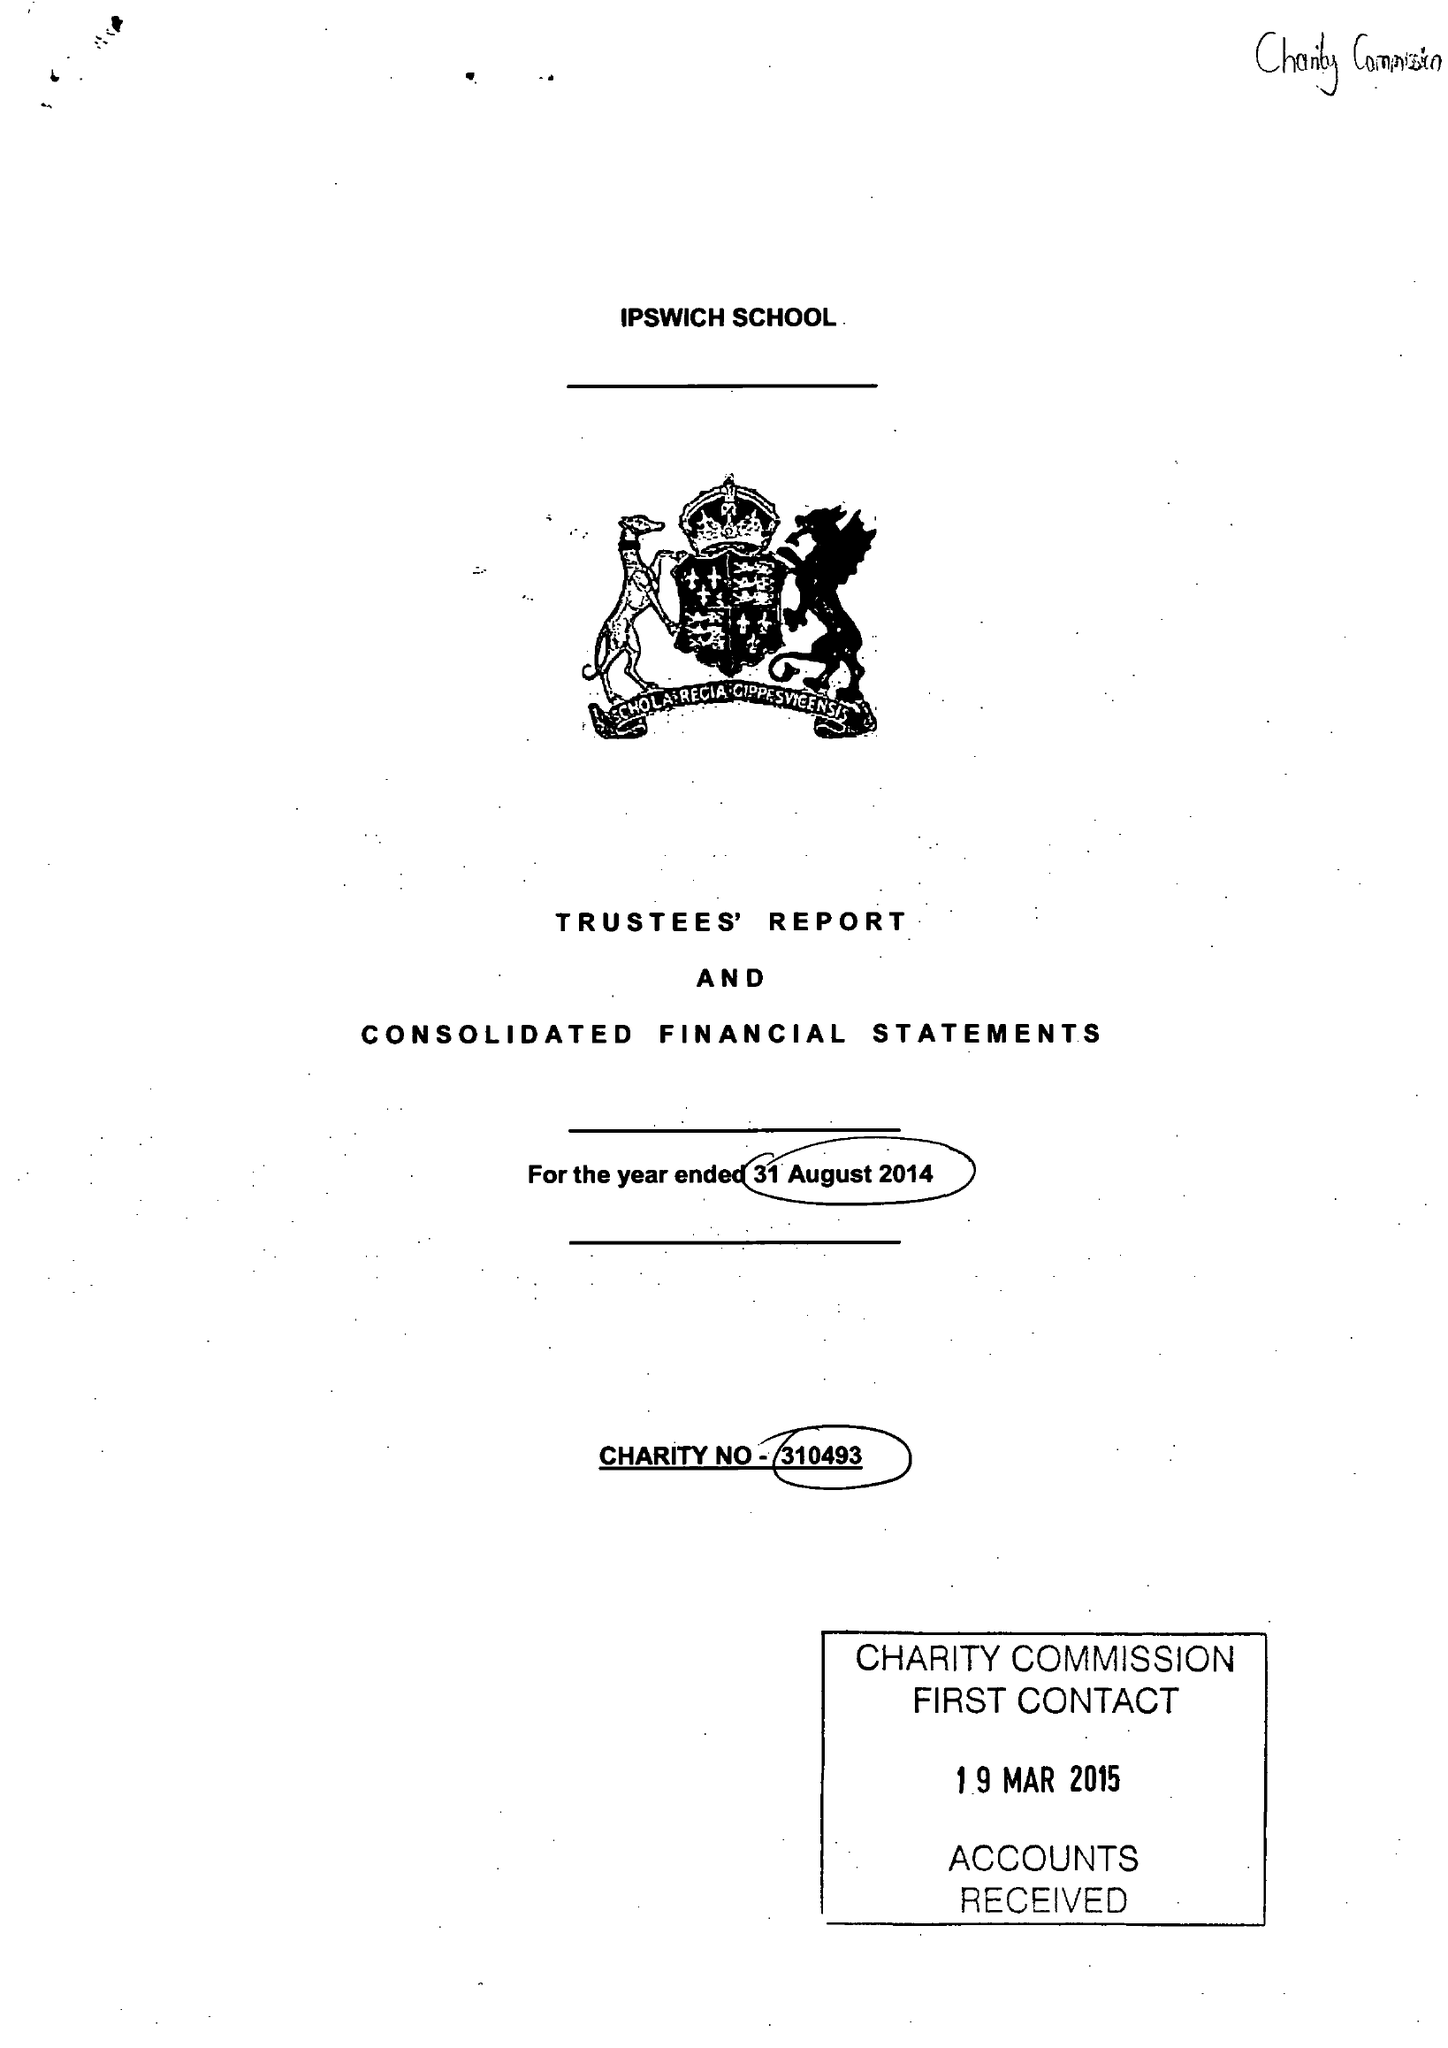What is the value for the address__street_line?
Answer the question using a single word or phrase. 25 HENLEY ROAD 